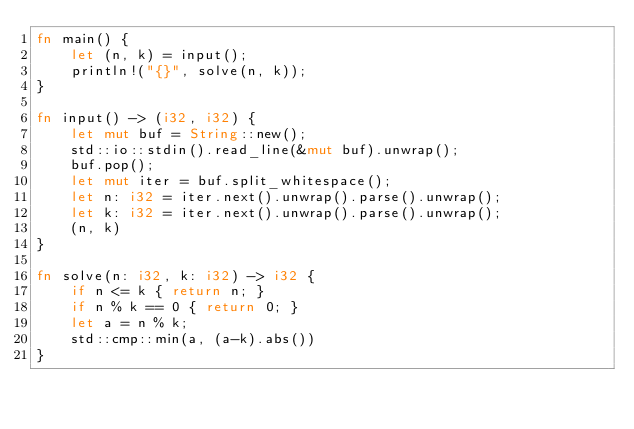Convert code to text. <code><loc_0><loc_0><loc_500><loc_500><_Rust_>fn main() {
    let (n, k) = input();
    println!("{}", solve(n, k));
}

fn input() -> (i32, i32) {
    let mut buf = String::new();
    std::io::stdin().read_line(&mut buf).unwrap();
    buf.pop();
    let mut iter = buf.split_whitespace();
    let n: i32 = iter.next().unwrap().parse().unwrap();
    let k: i32 = iter.next().unwrap().parse().unwrap();
    (n, k)
}

fn solve(n: i32, k: i32) -> i32 {
    if n <= k { return n; }
    if n % k == 0 { return 0; }
    let a = n % k;
    std::cmp::min(a, (a-k).abs())
}
</code> 